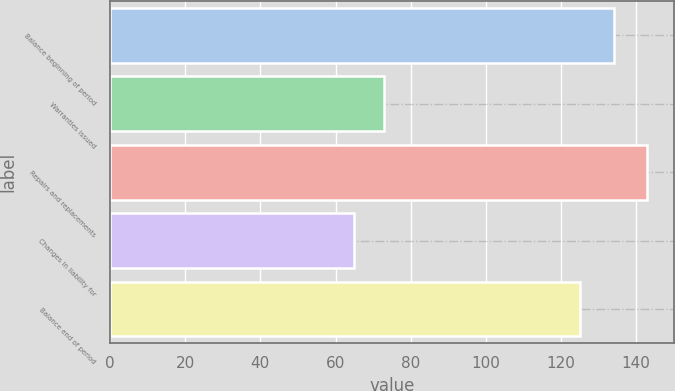<chart> <loc_0><loc_0><loc_500><loc_500><bar_chart><fcel>Balance beginning of period<fcel>Warranties issued<fcel>Repairs and replacements<fcel>Changes in liability for<fcel>Balance end of period<nl><fcel>134<fcel>72.8<fcel>143<fcel>65<fcel>125<nl></chart> 